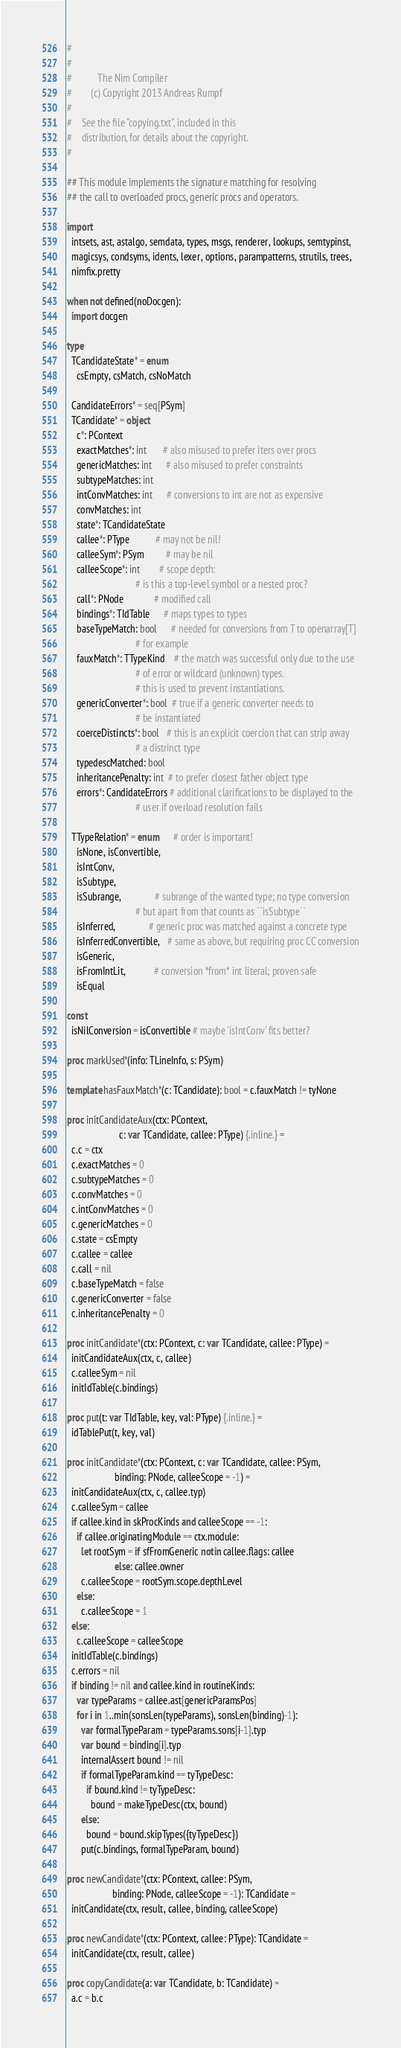<code> <loc_0><loc_0><loc_500><loc_500><_Nim_>#
#
#           The Nim Compiler
#        (c) Copyright 2013 Andreas Rumpf
#
#    See the file "copying.txt", included in this
#    distribution, for details about the copyright.
#

## This module implements the signature matching for resolving
## the call to overloaded procs, generic procs and operators.

import 
  intsets, ast, astalgo, semdata, types, msgs, renderer, lookups, semtypinst,
  magicsys, condsyms, idents, lexer, options, parampatterns, strutils, trees,
  nimfix.pretty

when not defined(noDocgen):
  import docgen

type
  TCandidateState* = enum 
    csEmpty, csMatch, csNoMatch

  CandidateErrors* = seq[PSym]
  TCandidate* = object
    c*: PContext
    exactMatches*: int       # also misused to prefer iters over procs
    genericMatches: int      # also misused to prefer constraints
    subtypeMatches: int
    intConvMatches: int      # conversions to int are not as expensive
    convMatches: int
    state*: TCandidateState
    callee*: PType           # may not be nil!
    calleeSym*: PSym         # may be nil
    calleeScope*: int        # scope depth:
                             # is this a top-level symbol or a nested proc?
    call*: PNode             # modified call
    bindings*: TIdTable      # maps types to types
    baseTypeMatch: bool      # needed for conversions from T to openarray[T]
                             # for example
    fauxMatch*: TTypeKind    # the match was successful only due to the use
                             # of error or wildcard (unknown) types.
                             # this is used to prevent instantiations.
    genericConverter*: bool  # true if a generic converter needs to
                             # be instantiated
    coerceDistincts*: bool   # this is an explicit coercion that can strip away
                             # a distrinct type
    typedescMatched: bool
    inheritancePenalty: int  # to prefer closest father object type
    errors*: CandidateErrors # additional clarifications to be displayed to the
                             # user if overload resolution fails

  TTypeRelation* = enum      # order is important!
    isNone, isConvertible,
    isIntConv,
    isSubtype,
    isSubrange,              # subrange of the wanted type; no type conversion
                             # but apart from that counts as ``isSubtype``
    isInferred,              # generic proc was matched against a concrete type
    isInferredConvertible,   # same as above, but requiring proc CC conversion
    isGeneric,
    isFromIntLit,            # conversion *from* int literal; proven safe
    isEqual
  
const
  isNilConversion = isConvertible # maybe 'isIntConv' fits better?
    
proc markUsed*(info: TLineInfo, s: PSym)

template hasFauxMatch*(c: TCandidate): bool = c.fauxMatch != tyNone

proc initCandidateAux(ctx: PContext,
                      c: var TCandidate, callee: PType) {.inline.} =
  c.c = ctx
  c.exactMatches = 0
  c.subtypeMatches = 0
  c.convMatches = 0
  c.intConvMatches = 0
  c.genericMatches = 0
  c.state = csEmpty
  c.callee = callee
  c.call = nil
  c.baseTypeMatch = false
  c.genericConverter = false
  c.inheritancePenalty = 0

proc initCandidate*(ctx: PContext, c: var TCandidate, callee: PType) =
  initCandidateAux(ctx, c, callee)
  c.calleeSym = nil
  initIdTable(c.bindings)

proc put(t: var TIdTable, key, val: PType) {.inline.} =
  idTablePut(t, key, val)

proc initCandidate*(ctx: PContext, c: var TCandidate, callee: PSym,
                    binding: PNode, calleeScope = -1) =
  initCandidateAux(ctx, c, callee.typ)
  c.calleeSym = callee
  if callee.kind in skProcKinds and calleeScope == -1:
    if callee.originatingModule == ctx.module:
      let rootSym = if sfFromGeneric notin callee.flags: callee
                    else: callee.owner
      c.calleeScope = rootSym.scope.depthLevel
    else:
      c.calleeScope = 1
  else:
    c.calleeScope = calleeScope
  initIdTable(c.bindings)
  c.errors = nil
  if binding != nil and callee.kind in routineKinds:
    var typeParams = callee.ast[genericParamsPos]
    for i in 1..min(sonsLen(typeParams), sonsLen(binding)-1):
      var formalTypeParam = typeParams.sons[i-1].typ
      var bound = binding[i].typ
      internalAssert bound != nil
      if formalTypeParam.kind == tyTypeDesc:
        if bound.kind != tyTypeDesc:
          bound = makeTypeDesc(ctx, bound)
      else:
        bound = bound.skipTypes({tyTypeDesc})
      put(c.bindings, formalTypeParam, bound)

proc newCandidate*(ctx: PContext, callee: PSym,
                   binding: PNode, calleeScope = -1): TCandidate =
  initCandidate(ctx, result, callee, binding, calleeScope)

proc newCandidate*(ctx: PContext, callee: PType): TCandidate =
  initCandidate(ctx, result, callee)

proc copyCandidate(a: var TCandidate, b: TCandidate) = 
  a.c = b.c</code> 